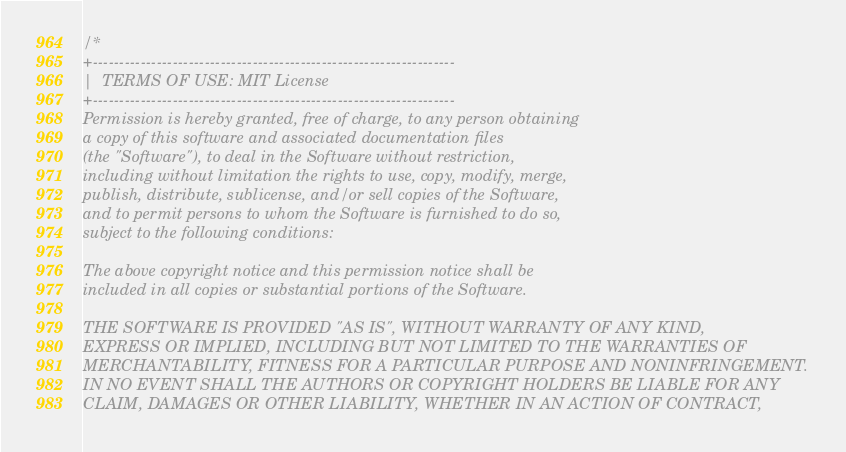Convert code to text. <code><loc_0><loc_0><loc_500><loc_500><_C_>/*
+--------------------------------------------------------------------
|  TERMS OF USE: MIT License
+--------------------------------------------------------------------
Permission is hereby granted, free of charge, to any person obtaining
a copy of this software and associated documentation files
(the "Software"), to deal in the Software without restriction,
including without limitation the rights to use, copy, modify, merge,
publish, distribute, sublicense, and/or sell copies of the Software,
and to permit persons to whom the Software is furnished to do so,
subject to the following conditions:

The above copyright notice and this permission notice shall be
included in all copies or substantial portions of the Software.

THE SOFTWARE IS PROVIDED "AS IS", WITHOUT WARRANTY OF ANY KIND,
EXPRESS OR IMPLIED, INCLUDING BUT NOT LIMITED TO THE WARRANTIES OF
MERCHANTABILITY, FITNESS FOR A PARTICULAR PURPOSE AND NONINFRINGEMENT.
IN NO EVENT SHALL THE AUTHORS OR COPYRIGHT HOLDERS BE LIABLE FOR ANY
CLAIM, DAMAGES OR OTHER LIABILITY, WHETHER IN AN ACTION OF CONTRACT,</code> 